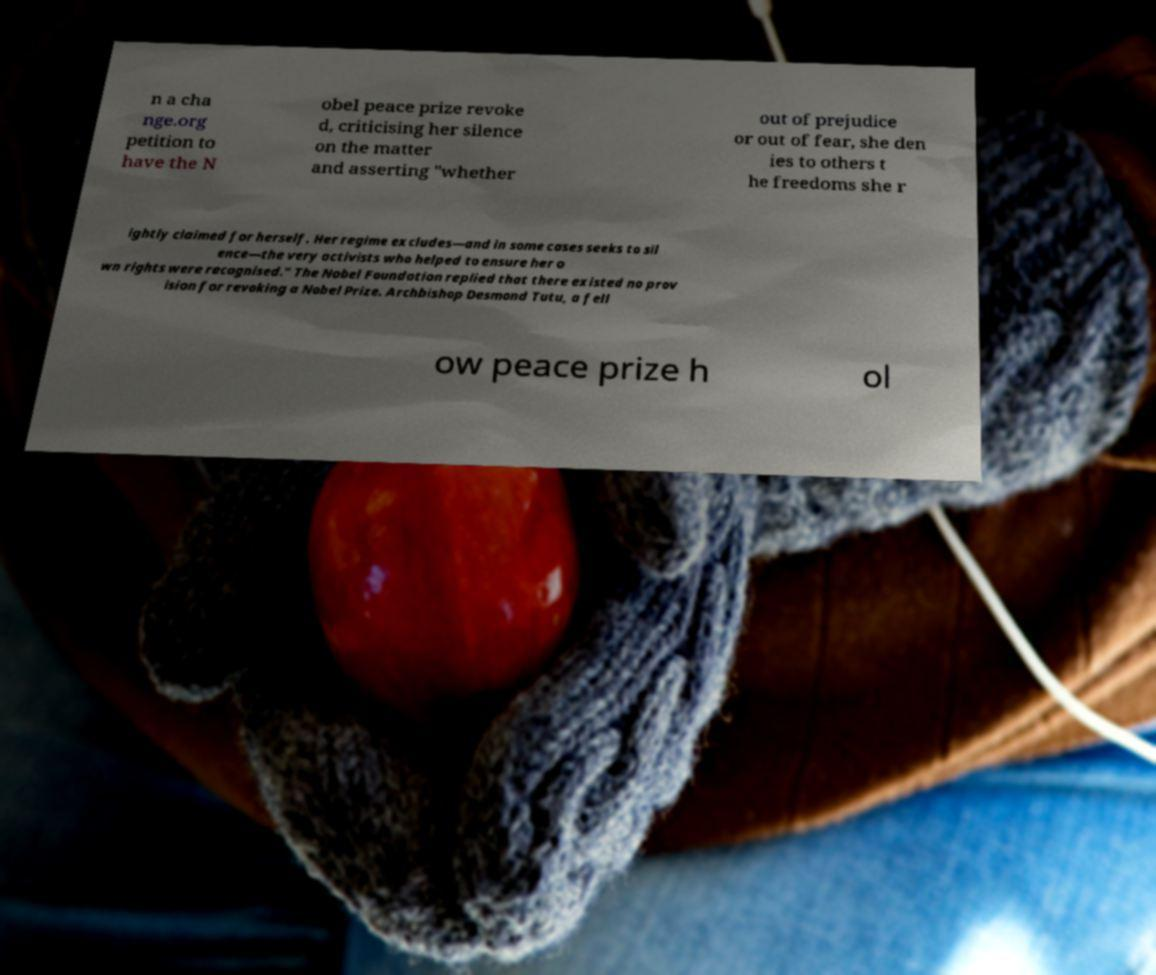Can you accurately transcribe the text from the provided image for me? n a cha nge.org petition to have the N obel peace prize revoke d, criticising her silence on the matter and asserting "whether out of prejudice or out of fear, she den ies to others t he freedoms she r ightly claimed for herself. Her regime excludes—and in some cases seeks to sil ence—the very activists who helped to ensure her o wn rights were recognised." The Nobel Foundation replied that there existed no prov ision for revoking a Nobel Prize. Archbishop Desmond Tutu, a fell ow peace prize h ol 